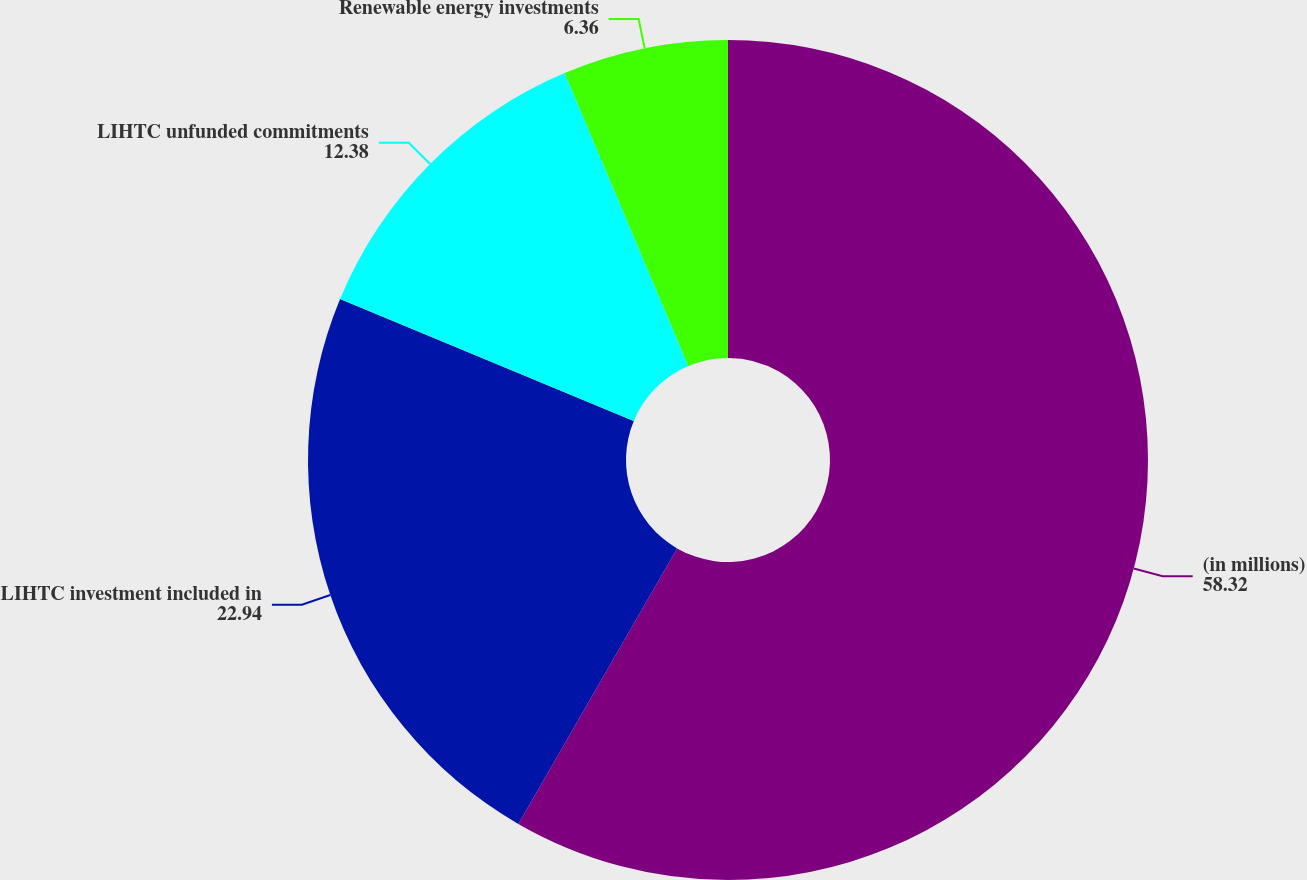<chart> <loc_0><loc_0><loc_500><loc_500><pie_chart><fcel>(in millions)<fcel>LIHTC investment included in<fcel>LIHTC unfunded commitments<fcel>Renewable energy investments<nl><fcel>58.32%<fcel>22.94%<fcel>12.38%<fcel>6.36%<nl></chart> 